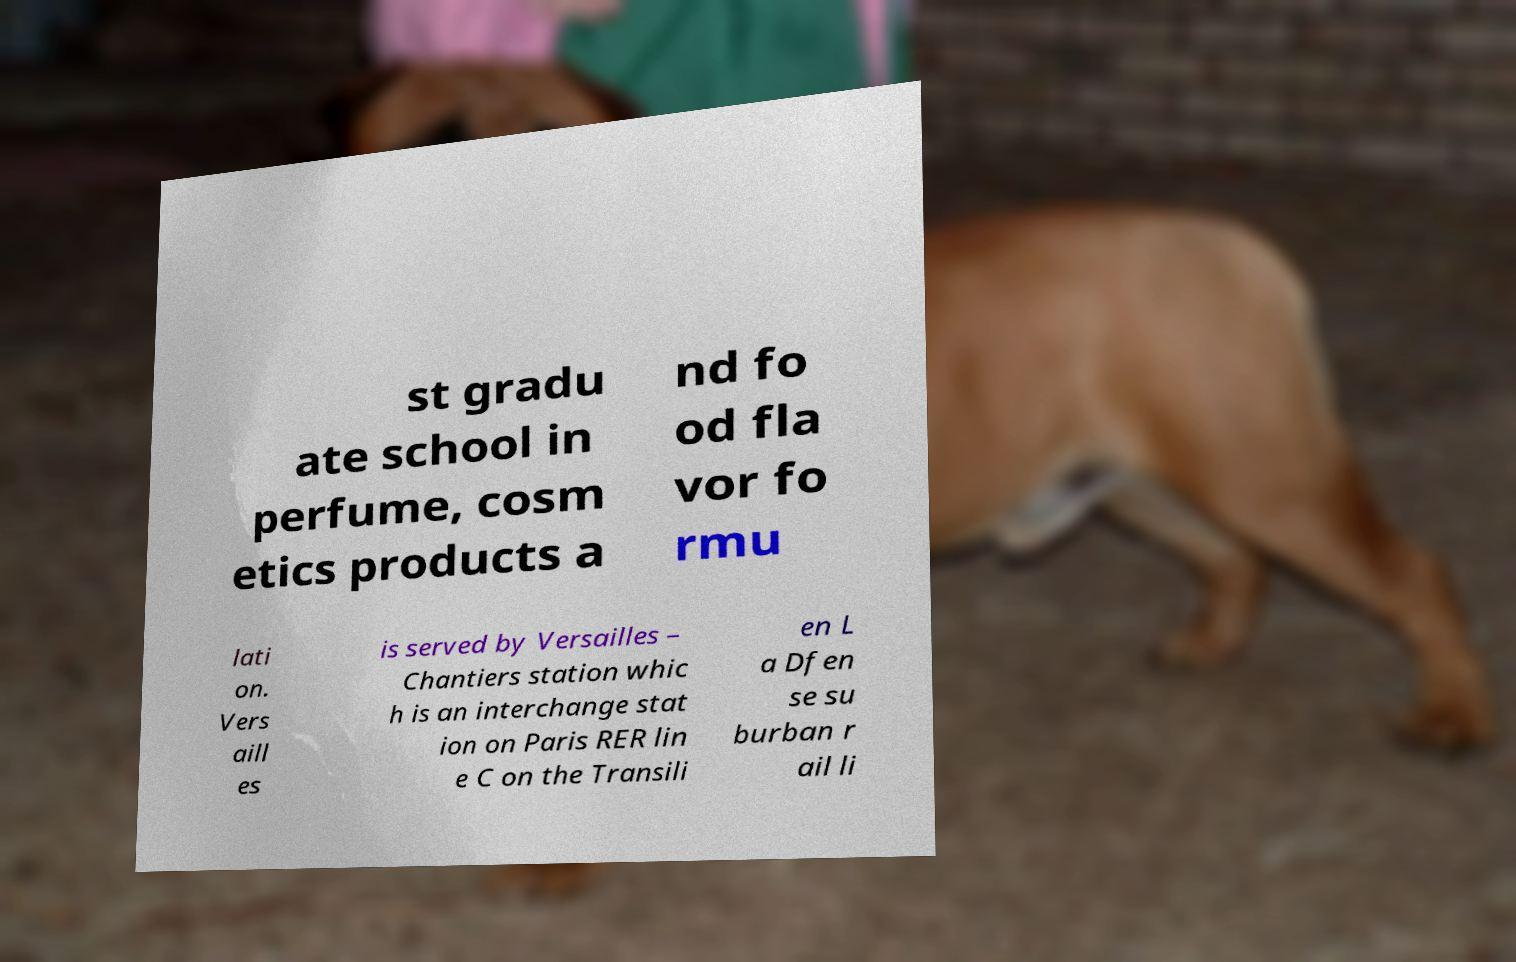Please identify and transcribe the text found in this image. st gradu ate school in perfume, cosm etics products a nd fo od fla vor fo rmu lati on. Vers aill es is served by Versailles – Chantiers station whic h is an interchange stat ion on Paris RER lin e C on the Transili en L a Dfen se su burban r ail li 